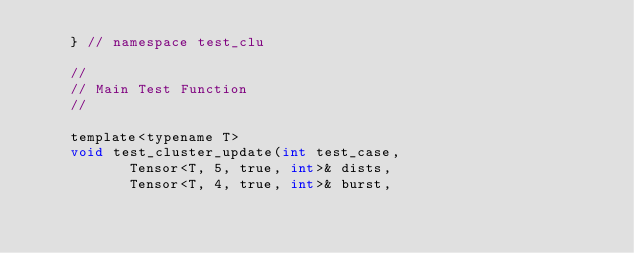Convert code to text. <code><loc_0><loc_0><loc_500><loc_500><_Cuda_>    } // namespace test_clu

    //
    // Main Test Function 
    //

    template<typename T>
    void test_cluster_update(int test_case,
			     Tensor<T, 5, true, int>& dists,
			     Tensor<T, 4, true, int>& burst,</code> 